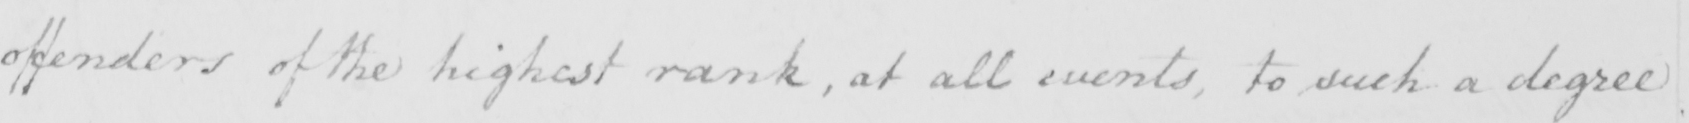Please transcribe the handwritten text in this image. offenders of the highest rank , at all events , to such a degree 